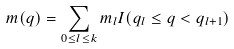Convert formula to latex. <formula><loc_0><loc_0><loc_500><loc_500>m ( q ) = \sum _ { 0 \leq l \leq k } m _ { l } I ( q _ { l } \leq q < q _ { l + 1 } )</formula> 